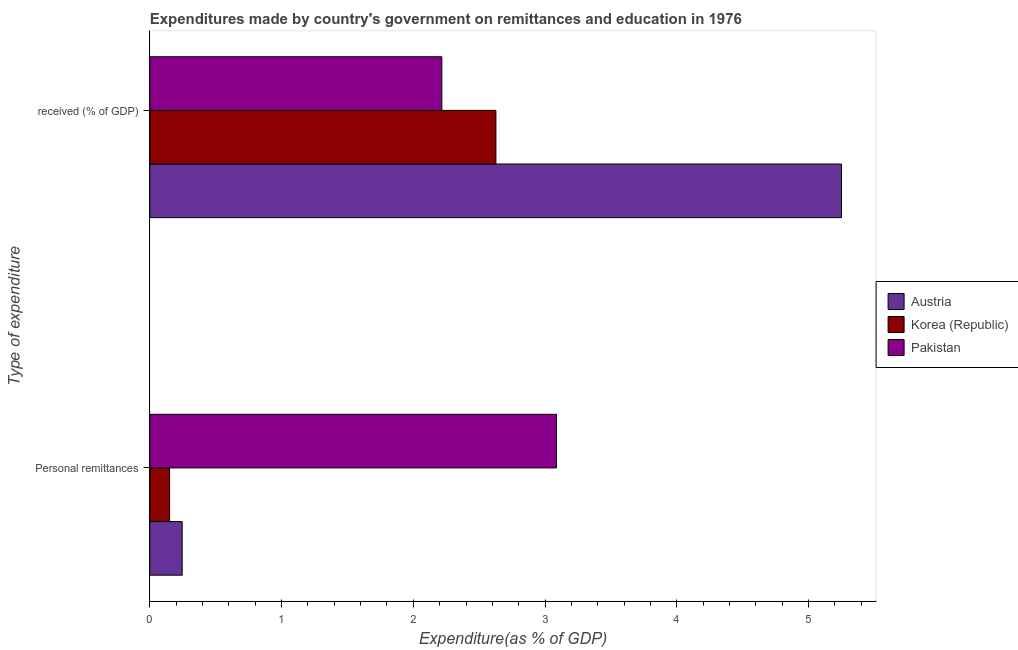Are the number of bars per tick equal to the number of legend labels?
Provide a succinct answer. Yes. What is the label of the 2nd group of bars from the top?
Ensure brevity in your answer.  Personal remittances. What is the expenditure in education in Pakistan?
Your answer should be very brief. 2.22. Across all countries, what is the maximum expenditure in personal remittances?
Provide a succinct answer. 3.09. Across all countries, what is the minimum expenditure in personal remittances?
Your answer should be very brief. 0.15. In which country was the expenditure in education maximum?
Your answer should be compact. Austria. In which country was the expenditure in personal remittances minimum?
Provide a succinct answer. Korea (Republic). What is the total expenditure in education in the graph?
Your answer should be very brief. 10.09. What is the difference between the expenditure in personal remittances in Pakistan and that in Austria?
Your response must be concise. 2.84. What is the difference between the expenditure in personal remittances in Austria and the expenditure in education in Pakistan?
Your answer should be very brief. -1.97. What is the average expenditure in personal remittances per country?
Provide a succinct answer. 1.16. What is the difference between the expenditure in personal remittances and expenditure in education in Pakistan?
Provide a succinct answer. 0.87. What is the ratio of the expenditure in education in Pakistan to that in Austria?
Offer a very short reply. 0.42. Is the expenditure in personal remittances in Pakistan less than that in Austria?
Your answer should be very brief. No. What does the 2nd bar from the top in  received (% of GDP) represents?
Give a very brief answer. Korea (Republic). What does the 3rd bar from the bottom in Personal remittances represents?
Provide a succinct answer. Pakistan. How many bars are there?
Provide a short and direct response. 6. What is the difference between two consecutive major ticks on the X-axis?
Make the answer very short. 1. Are the values on the major ticks of X-axis written in scientific E-notation?
Provide a short and direct response. No. Does the graph contain any zero values?
Give a very brief answer. No. Does the graph contain grids?
Ensure brevity in your answer.  No. Where does the legend appear in the graph?
Keep it short and to the point. Center right. How many legend labels are there?
Offer a terse response. 3. What is the title of the graph?
Keep it short and to the point. Expenditures made by country's government on remittances and education in 1976. Does "Bangladesh" appear as one of the legend labels in the graph?
Ensure brevity in your answer.  No. What is the label or title of the X-axis?
Keep it short and to the point. Expenditure(as % of GDP). What is the label or title of the Y-axis?
Provide a succinct answer. Type of expenditure. What is the Expenditure(as % of GDP) of Austria in Personal remittances?
Give a very brief answer. 0.25. What is the Expenditure(as % of GDP) of Korea (Republic) in Personal remittances?
Make the answer very short. 0.15. What is the Expenditure(as % of GDP) in Pakistan in Personal remittances?
Ensure brevity in your answer.  3.09. What is the Expenditure(as % of GDP) in Austria in  received (% of GDP)?
Keep it short and to the point. 5.25. What is the Expenditure(as % of GDP) in Korea (Republic) in  received (% of GDP)?
Give a very brief answer. 2.63. What is the Expenditure(as % of GDP) of Pakistan in  received (% of GDP)?
Offer a very short reply. 2.22. Across all Type of expenditure, what is the maximum Expenditure(as % of GDP) in Austria?
Provide a short and direct response. 5.25. Across all Type of expenditure, what is the maximum Expenditure(as % of GDP) in Korea (Republic)?
Provide a short and direct response. 2.63. Across all Type of expenditure, what is the maximum Expenditure(as % of GDP) in Pakistan?
Your response must be concise. 3.09. Across all Type of expenditure, what is the minimum Expenditure(as % of GDP) in Austria?
Your answer should be compact. 0.25. Across all Type of expenditure, what is the minimum Expenditure(as % of GDP) in Korea (Republic)?
Offer a terse response. 0.15. Across all Type of expenditure, what is the minimum Expenditure(as % of GDP) in Pakistan?
Ensure brevity in your answer.  2.22. What is the total Expenditure(as % of GDP) in Austria in the graph?
Offer a terse response. 5.5. What is the total Expenditure(as % of GDP) of Korea (Republic) in the graph?
Make the answer very short. 2.78. What is the total Expenditure(as % of GDP) of Pakistan in the graph?
Make the answer very short. 5.3. What is the difference between the Expenditure(as % of GDP) in Austria in Personal remittances and that in  received (% of GDP)?
Keep it short and to the point. -5. What is the difference between the Expenditure(as % of GDP) in Korea (Republic) in Personal remittances and that in  received (% of GDP)?
Offer a terse response. -2.48. What is the difference between the Expenditure(as % of GDP) in Pakistan in Personal remittances and that in  received (% of GDP)?
Keep it short and to the point. 0.87. What is the difference between the Expenditure(as % of GDP) in Austria in Personal remittances and the Expenditure(as % of GDP) in Korea (Republic) in  received (% of GDP)?
Offer a very short reply. -2.38. What is the difference between the Expenditure(as % of GDP) in Austria in Personal remittances and the Expenditure(as % of GDP) in Pakistan in  received (% of GDP)?
Your response must be concise. -1.97. What is the difference between the Expenditure(as % of GDP) of Korea (Republic) in Personal remittances and the Expenditure(as % of GDP) of Pakistan in  received (% of GDP)?
Offer a very short reply. -2.07. What is the average Expenditure(as % of GDP) in Austria per Type of expenditure?
Offer a terse response. 2.75. What is the average Expenditure(as % of GDP) in Korea (Republic) per Type of expenditure?
Provide a short and direct response. 1.39. What is the average Expenditure(as % of GDP) in Pakistan per Type of expenditure?
Offer a terse response. 2.65. What is the difference between the Expenditure(as % of GDP) in Austria and Expenditure(as % of GDP) in Korea (Republic) in Personal remittances?
Your answer should be very brief. 0.1. What is the difference between the Expenditure(as % of GDP) in Austria and Expenditure(as % of GDP) in Pakistan in Personal remittances?
Make the answer very short. -2.84. What is the difference between the Expenditure(as % of GDP) in Korea (Republic) and Expenditure(as % of GDP) in Pakistan in Personal remittances?
Make the answer very short. -2.94. What is the difference between the Expenditure(as % of GDP) of Austria and Expenditure(as % of GDP) of Korea (Republic) in  received (% of GDP)?
Ensure brevity in your answer.  2.62. What is the difference between the Expenditure(as % of GDP) in Austria and Expenditure(as % of GDP) in Pakistan in  received (% of GDP)?
Provide a short and direct response. 3.03. What is the difference between the Expenditure(as % of GDP) in Korea (Republic) and Expenditure(as % of GDP) in Pakistan in  received (% of GDP)?
Keep it short and to the point. 0.41. What is the ratio of the Expenditure(as % of GDP) of Austria in Personal remittances to that in  received (% of GDP)?
Keep it short and to the point. 0.05. What is the ratio of the Expenditure(as % of GDP) in Korea (Republic) in Personal remittances to that in  received (% of GDP)?
Offer a terse response. 0.06. What is the ratio of the Expenditure(as % of GDP) in Pakistan in Personal remittances to that in  received (% of GDP)?
Offer a very short reply. 1.39. What is the difference between the highest and the second highest Expenditure(as % of GDP) of Austria?
Provide a short and direct response. 5. What is the difference between the highest and the second highest Expenditure(as % of GDP) in Korea (Republic)?
Your answer should be compact. 2.48. What is the difference between the highest and the second highest Expenditure(as % of GDP) in Pakistan?
Give a very brief answer. 0.87. What is the difference between the highest and the lowest Expenditure(as % of GDP) in Austria?
Make the answer very short. 5. What is the difference between the highest and the lowest Expenditure(as % of GDP) in Korea (Republic)?
Keep it short and to the point. 2.48. What is the difference between the highest and the lowest Expenditure(as % of GDP) in Pakistan?
Make the answer very short. 0.87. 